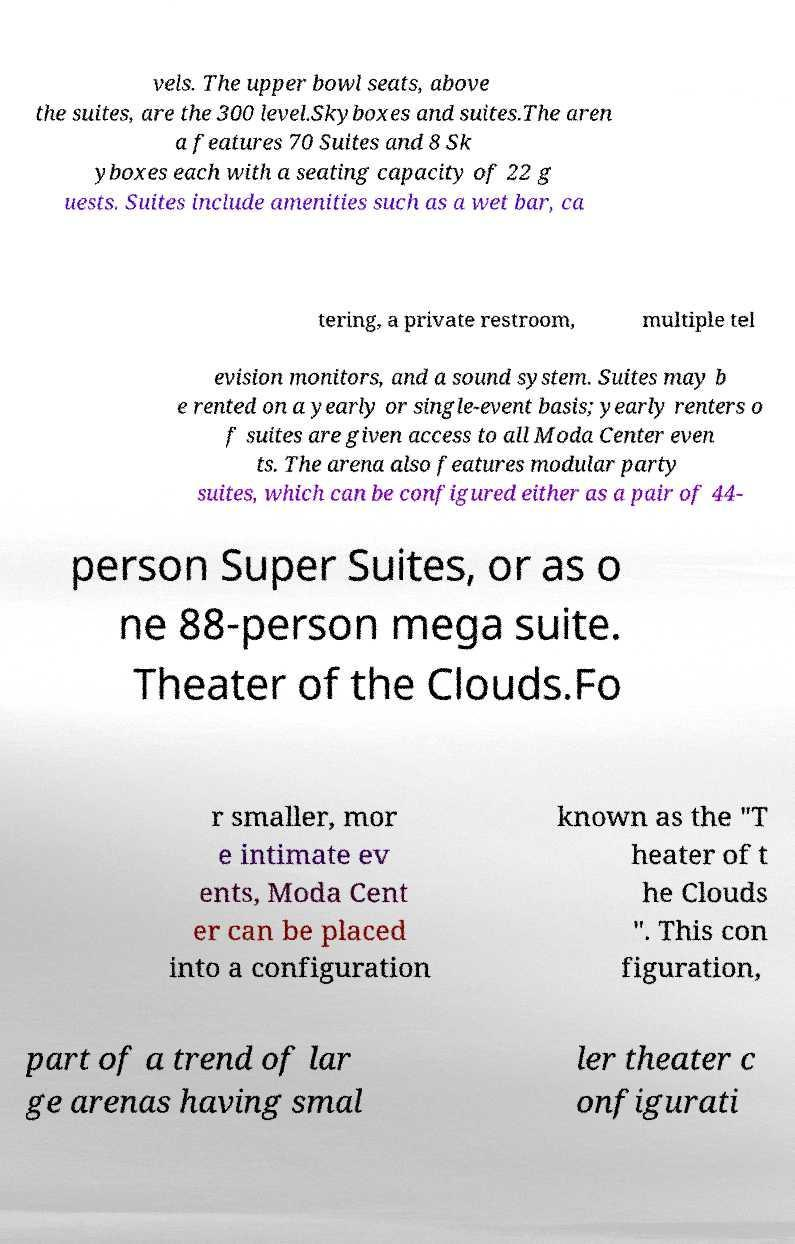For documentation purposes, I need the text within this image transcribed. Could you provide that? vels. The upper bowl seats, above the suites, are the 300 level.Skyboxes and suites.The aren a features 70 Suites and 8 Sk yboxes each with a seating capacity of 22 g uests. Suites include amenities such as a wet bar, ca tering, a private restroom, multiple tel evision monitors, and a sound system. Suites may b e rented on a yearly or single-event basis; yearly renters o f suites are given access to all Moda Center even ts. The arena also features modular party suites, which can be configured either as a pair of 44- person Super Suites, or as o ne 88-person mega suite. Theater of the Clouds.Fo r smaller, mor e intimate ev ents, Moda Cent er can be placed into a configuration known as the "T heater of t he Clouds ". This con figuration, part of a trend of lar ge arenas having smal ler theater c onfigurati 